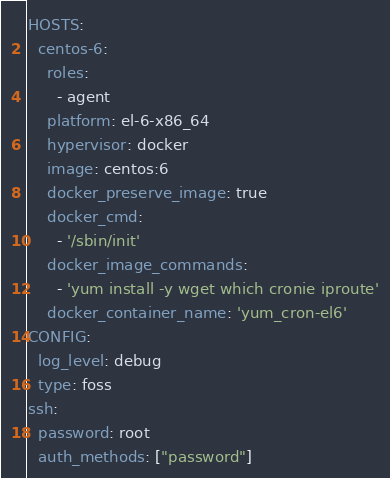Convert code to text. <code><loc_0><loc_0><loc_500><loc_500><_YAML_>HOSTS:
  centos-6:
    roles:
      - agent
    platform: el-6-x86_64
    hypervisor: docker
    image: centos:6
    docker_preserve_image: true
    docker_cmd:
      - '/sbin/init'
    docker_image_commands:
      - 'yum install -y wget which cronie iproute'
    docker_container_name: 'yum_cron-el6'
CONFIG:
  log_level: debug
  type: foss
ssh:
  password: root
  auth_methods: ["password"]

</code> 